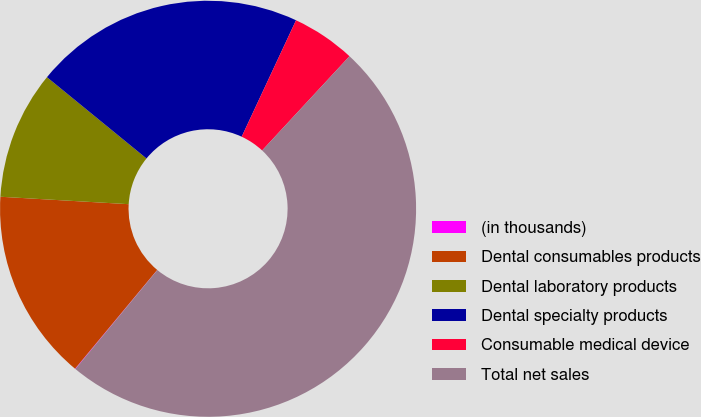Convert chart to OTSL. <chart><loc_0><loc_0><loc_500><loc_500><pie_chart><fcel>(in thousands)<fcel>Dental consumables products<fcel>Dental laboratory products<fcel>Dental specialty products<fcel>Consumable medical device<fcel>Total net sales<nl><fcel>0.04%<fcel>14.88%<fcel>9.98%<fcel>21.05%<fcel>4.95%<fcel>49.11%<nl></chart> 